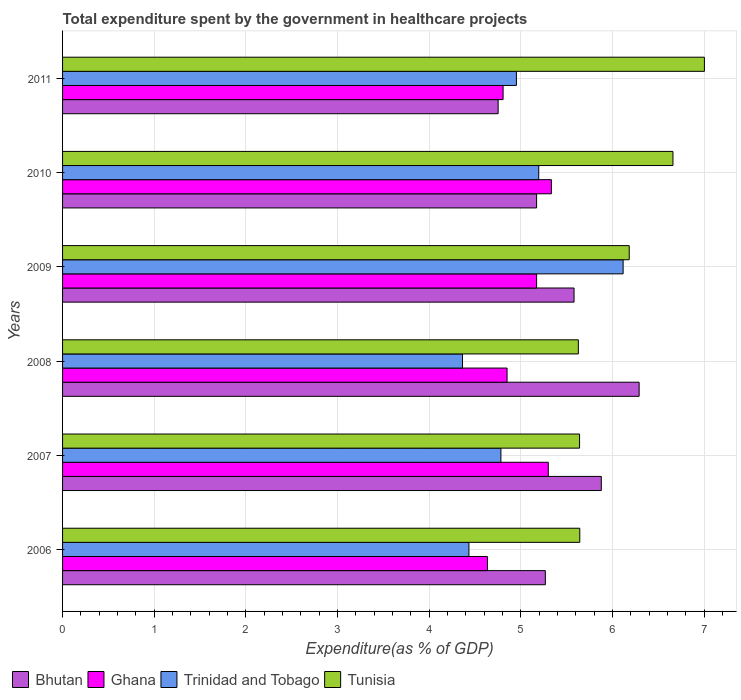What is the label of the 3rd group of bars from the top?
Your answer should be very brief. 2009. In how many cases, is the number of bars for a given year not equal to the number of legend labels?
Keep it short and to the point. 0. What is the total expenditure spent by the government in healthcare projects in Bhutan in 2009?
Keep it short and to the point. 5.58. Across all years, what is the maximum total expenditure spent by the government in healthcare projects in Bhutan?
Give a very brief answer. 6.29. Across all years, what is the minimum total expenditure spent by the government in healthcare projects in Tunisia?
Give a very brief answer. 5.63. In which year was the total expenditure spent by the government in healthcare projects in Tunisia maximum?
Your answer should be compact. 2011. In which year was the total expenditure spent by the government in healthcare projects in Trinidad and Tobago minimum?
Your response must be concise. 2008. What is the total total expenditure spent by the government in healthcare projects in Tunisia in the graph?
Provide a succinct answer. 36.76. What is the difference between the total expenditure spent by the government in healthcare projects in Bhutan in 2006 and that in 2011?
Your answer should be compact. 0.52. What is the difference between the total expenditure spent by the government in healthcare projects in Tunisia in 2010 and the total expenditure spent by the government in healthcare projects in Trinidad and Tobago in 2007?
Give a very brief answer. 1.88. What is the average total expenditure spent by the government in healthcare projects in Bhutan per year?
Your answer should be compact. 5.49. In the year 2011, what is the difference between the total expenditure spent by the government in healthcare projects in Bhutan and total expenditure spent by the government in healthcare projects in Trinidad and Tobago?
Your response must be concise. -0.2. In how many years, is the total expenditure spent by the government in healthcare projects in Trinidad and Tobago greater than 2.2 %?
Provide a short and direct response. 6. What is the ratio of the total expenditure spent by the government in healthcare projects in Bhutan in 2007 to that in 2010?
Make the answer very short. 1.14. Is the total expenditure spent by the government in healthcare projects in Bhutan in 2006 less than that in 2007?
Provide a succinct answer. Yes. What is the difference between the highest and the second highest total expenditure spent by the government in healthcare projects in Trinidad and Tobago?
Offer a very short reply. 0.92. What is the difference between the highest and the lowest total expenditure spent by the government in healthcare projects in Ghana?
Your response must be concise. 0.7. Is the sum of the total expenditure spent by the government in healthcare projects in Trinidad and Tobago in 2009 and 2011 greater than the maximum total expenditure spent by the government in healthcare projects in Tunisia across all years?
Offer a very short reply. Yes. Is it the case that in every year, the sum of the total expenditure spent by the government in healthcare projects in Ghana and total expenditure spent by the government in healthcare projects in Trinidad and Tobago is greater than the sum of total expenditure spent by the government in healthcare projects in Bhutan and total expenditure spent by the government in healthcare projects in Tunisia?
Your answer should be very brief. No. What does the 4th bar from the top in 2010 represents?
Your answer should be compact. Bhutan. What does the 3rd bar from the bottom in 2008 represents?
Your answer should be very brief. Trinidad and Tobago. Is it the case that in every year, the sum of the total expenditure spent by the government in healthcare projects in Tunisia and total expenditure spent by the government in healthcare projects in Bhutan is greater than the total expenditure spent by the government in healthcare projects in Ghana?
Keep it short and to the point. Yes. Are all the bars in the graph horizontal?
Your answer should be compact. Yes. What is the difference between two consecutive major ticks on the X-axis?
Give a very brief answer. 1. How many legend labels are there?
Offer a terse response. 4. What is the title of the graph?
Provide a short and direct response. Total expenditure spent by the government in healthcare projects. What is the label or title of the X-axis?
Give a very brief answer. Expenditure(as % of GDP). What is the label or title of the Y-axis?
Provide a short and direct response. Years. What is the Expenditure(as % of GDP) of Bhutan in 2006?
Give a very brief answer. 5.27. What is the Expenditure(as % of GDP) in Ghana in 2006?
Ensure brevity in your answer.  4.64. What is the Expenditure(as % of GDP) of Trinidad and Tobago in 2006?
Provide a short and direct response. 4.43. What is the Expenditure(as % of GDP) of Tunisia in 2006?
Offer a very short reply. 5.64. What is the Expenditure(as % of GDP) of Bhutan in 2007?
Make the answer very short. 5.88. What is the Expenditure(as % of GDP) in Ghana in 2007?
Provide a succinct answer. 5.3. What is the Expenditure(as % of GDP) in Trinidad and Tobago in 2007?
Make the answer very short. 4.78. What is the Expenditure(as % of GDP) in Tunisia in 2007?
Offer a very short reply. 5.64. What is the Expenditure(as % of GDP) of Bhutan in 2008?
Provide a short and direct response. 6.29. What is the Expenditure(as % of GDP) of Ghana in 2008?
Your answer should be compact. 4.85. What is the Expenditure(as % of GDP) in Trinidad and Tobago in 2008?
Your answer should be very brief. 4.36. What is the Expenditure(as % of GDP) in Tunisia in 2008?
Your answer should be compact. 5.63. What is the Expenditure(as % of GDP) in Bhutan in 2009?
Provide a succinct answer. 5.58. What is the Expenditure(as % of GDP) in Ghana in 2009?
Your answer should be compact. 5.17. What is the Expenditure(as % of GDP) in Trinidad and Tobago in 2009?
Provide a succinct answer. 6.12. What is the Expenditure(as % of GDP) in Tunisia in 2009?
Provide a succinct answer. 6.18. What is the Expenditure(as % of GDP) in Bhutan in 2010?
Ensure brevity in your answer.  5.17. What is the Expenditure(as % of GDP) of Ghana in 2010?
Provide a succinct answer. 5.33. What is the Expenditure(as % of GDP) in Trinidad and Tobago in 2010?
Your answer should be compact. 5.2. What is the Expenditure(as % of GDP) of Tunisia in 2010?
Keep it short and to the point. 6.66. What is the Expenditure(as % of GDP) of Bhutan in 2011?
Your answer should be very brief. 4.75. What is the Expenditure(as % of GDP) in Ghana in 2011?
Offer a very short reply. 4.81. What is the Expenditure(as % of GDP) in Trinidad and Tobago in 2011?
Ensure brevity in your answer.  4.95. What is the Expenditure(as % of GDP) in Tunisia in 2011?
Make the answer very short. 7. Across all years, what is the maximum Expenditure(as % of GDP) in Bhutan?
Your answer should be very brief. 6.29. Across all years, what is the maximum Expenditure(as % of GDP) of Ghana?
Provide a succinct answer. 5.33. Across all years, what is the maximum Expenditure(as % of GDP) in Trinidad and Tobago?
Make the answer very short. 6.12. Across all years, what is the maximum Expenditure(as % of GDP) in Tunisia?
Give a very brief answer. 7. Across all years, what is the minimum Expenditure(as % of GDP) in Bhutan?
Your response must be concise. 4.75. Across all years, what is the minimum Expenditure(as % of GDP) of Ghana?
Make the answer very short. 4.64. Across all years, what is the minimum Expenditure(as % of GDP) in Trinidad and Tobago?
Give a very brief answer. 4.36. Across all years, what is the minimum Expenditure(as % of GDP) in Tunisia?
Keep it short and to the point. 5.63. What is the total Expenditure(as % of GDP) of Bhutan in the graph?
Offer a terse response. 32.95. What is the total Expenditure(as % of GDP) in Ghana in the graph?
Your response must be concise. 30.1. What is the total Expenditure(as % of GDP) in Trinidad and Tobago in the graph?
Provide a succinct answer. 29.85. What is the total Expenditure(as % of GDP) in Tunisia in the graph?
Your answer should be very brief. 36.76. What is the difference between the Expenditure(as % of GDP) in Bhutan in 2006 and that in 2007?
Keep it short and to the point. -0.61. What is the difference between the Expenditure(as % of GDP) of Ghana in 2006 and that in 2007?
Your answer should be compact. -0.66. What is the difference between the Expenditure(as % of GDP) of Trinidad and Tobago in 2006 and that in 2007?
Keep it short and to the point. -0.35. What is the difference between the Expenditure(as % of GDP) in Tunisia in 2006 and that in 2007?
Your answer should be very brief. 0. What is the difference between the Expenditure(as % of GDP) in Bhutan in 2006 and that in 2008?
Offer a terse response. -1.02. What is the difference between the Expenditure(as % of GDP) in Ghana in 2006 and that in 2008?
Offer a very short reply. -0.21. What is the difference between the Expenditure(as % of GDP) of Trinidad and Tobago in 2006 and that in 2008?
Make the answer very short. 0.07. What is the difference between the Expenditure(as % of GDP) in Tunisia in 2006 and that in 2008?
Your answer should be very brief. 0.02. What is the difference between the Expenditure(as % of GDP) of Bhutan in 2006 and that in 2009?
Offer a terse response. -0.31. What is the difference between the Expenditure(as % of GDP) of Ghana in 2006 and that in 2009?
Your answer should be compact. -0.54. What is the difference between the Expenditure(as % of GDP) in Trinidad and Tobago in 2006 and that in 2009?
Keep it short and to the point. -1.68. What is the difference between the Expenditure(as % of GDP) of Tunisia in 2006 and that in 2009?
Your answer should be compact. -0.54. What is the difference between the Expenditure(as % of GDP) in Bhutan in 2006 and that in 2010?
Provide a succinct answer. 0.1. What is the difference between the Expenditure(as % of GDP) in Ghana in 2006 and that in 2010?
Your answer should be compact. -0.7. What is the difference between the Expenditure(as % of GDP) in Trinidad and Tobago in 2006 and that in 2010?
Your response must be concise. -0.76. What is the difference between the Expenditure(as % of GDP) in Tunisia in 2006 and that in 2010?
Your answer should be very brief. -1.02. What is the difference between the Expenditure(as % of GDP) of Bhutan in 2006 and that in 2011?
Provide a succinct answer. 0.52. What is the difference between the Expenditure(as % of GDP) of Ghana in 2006 and that in 2011?
Provide a succinct answer. -0.17. What is the difference between the Expenditure(as % of GDP) in Trinidad and Tobago in 2006 and that in 2011?
Offer a very short reply. -0.52. What is the difference between the Expenditure(as % of GDP) in Tunisia in 2006 and that in 2011?
Your answer should be very brief. -1.36. What is the difference between the Expenditure(as % of GDP) in Bhutan in 2007 and that in 2008?
Offer a terse response. -0.41. What is the difference between the Expenditure(as % of GDP) in Ghana in 2007 and that in 2008?
Your answer should be very brief. 0.45. What is the difference between the Expenditure(as % of GDP) in Trinidad and Tobago in 2007 and that in 2008?
Offer a terse response. 0.42. What is the difference between the Expenditure(as % of GDP) of Tunisia in 2007 and that in 2008?
Ensure brevity in your answer.  0.01. What is the difference between the Expenditure(as % of GDP) of Bhutan in 2007 and that in 2009?
Offer a terse response. 0.3. What is the difference between the Expenditure(as % of GDP) of Ghana in 2007 and that in 2009?
Keep it short and to the point. 0.13. What is the difference between the Expenditure(as % of GDP) in Trinidad and Tobago in 2007 and that in 2009?
Your answer should be compact. -1.33. What is the difference between the Expenditure(as % of GDP) of Tunisia in 2007 and that in 2009?
Your response must be concise. -0.54. What is the difference between the Expenditure(as % of GDP) of Bhutan in 2007 and that in 2010?
Your answer should be very brief. 0.71. What is the difference between the Expenditure(as % of GDP) of Ghana in 2007 and that in 2010?
Give a very brief answer. -0.03. What is the difference between the Expenditure(as % of GDP) in Trinidad and Tobago in 2007 and that in 2010?
Offer a very short reply. -0.41. What is the difference between the Expenditure(as % of GDP) of Tunisia in 2007 and that in 2010?
Keep it short and to the point. -1.02. What is the difference between the Expenditure(as % of GDP) of Bhutan in 2007 and that in 2011?
Your answer should be compact. 1.13. What is the difference between the Expenditure(as % of GDP) of Ghana in 2007 and that in 2011?
Ensure brevity in your answer.  0.49. What is the difference between the Expenditure(as % of GDP) in Trinidad and Tobago in 2007 and that in 2011?
Provide a succinct answer. -0.17. What is the difference between the Expenditure(as % of GDP) of Tunisia in 2007 and that in 2011?
Keep it short and to the point. -1.36. What is the difference between the Expenditure(as % of GDP) of Bhutan in 2008 and that in 2009?
Make the answer very short. 0.71. What is the difference between the Expenditure(as % of GDP) of Ghana in 2008 and that in 2009?
Make the answer very short. -0.32. What is the difference between the Expenditure(as % of GDP) of Trinidad and Tobago in 2008 and that in 2009?
Provide a succinct answer. -1.75. What is the difference between the Expenditure(as % of GDP) in Tunisia in 2008 and that in 2009?
Make the answer very short. -0.56. What is the difference between the Expenditure(as % of GDP) of Bhutan in 2008 and that in 2010?
Keep it short and to the point. 1.12. What is the difference between the Expenditure(as % of GDP) of Ghana in 2008 and that in 2010?
Offer a very short reply. -0.48. What is the difference between the Expenditure(as % of GDP) of Trinidad and Tobago in 2008 and that in 2010?
Ensure brevity in your answer.  -0.83. What is the difference between the Expenditure(as % of GDP) of Tunisia in 2008 and that in 2010?
Your response must be concise. -1.03. What is the difference between the Expenditure(as % of GDP) in Bhutan in 2008 and that in 2011?
Give a very brief answer. 1.54. What is the difference between the Expenditure(as % of GDP) in Ghana in 2008 and that in 2011?
Your answer should be very brief. 0.04. What is the difference between the Expenditure(as % of GDP) in Trinidad and Tobago in 2008 and that in 2011?
Provide a succinct answer. -0.59. What is the difference between the Expenditure(as % of GDP) in Tunisia in 2008 and that in 2011?
Give a very brief answer. -1.38. What is the difference between the Expenditure(as % of GDP) in Bhutan in 2009 and that in 2010?
Make the answer very short. 0.41. What is the difference between the Expenditure(as % of GDP) of Ghana in 2009 and that in 2010?
Provide a succinct answer. -0.16. What is the difference between the Expenditure(as % of GDP) of Trinidad and Tobago in 2009 and that in 2010?
Give a very brief answer. 0.92. What is the difference between the Expenditure(as % of GDP) of Tunisia in 2009 and that in 2010?
Provide a short and direct response. -0.48. What is the difference between the Expenditure(as % of GDP) in Bhutan in 2009 and that in 2011?
Provide a short and direct response. 0.83. What is the difference between the Expenditure(as % of GDP) of Ghana in 2009 and that in 2011?
Offer a terse response. 0.37. What is the difference between the Expenditure(as % of GDP) of Trinidad and Tobago in 2009 and that in 2011?
Provide a succinct answer. 1.16. What is the difference between the Expenditure(as % of GDP) in Tunisia in 2009 and that in 2011?
Offer a terse response. -0.82. What is the difference between the Expenditure(as % of GDP) in Bhutan in 2010 and that in 2011?
Your answer should be compact. 0.42. What is the difference between the Expenditure(as % of GDP) in Ghana in 2010 and that in 2011?
Your answer should be very brief. 0.53. What is the difference between the Expenditure(as % of GDP) of Trinidad and Tobago in 2010 and that in 2011?
Your answer should be very brief. 0.24. What is the difference between the Expenditure(as % of GDP) of Tunisia in 2010 and that in 2011?
Offer a very short reply. -0.34. What is the difference between the Expenditure(as % of GDP) of Bhutan in 2006 and the Expenditure(as % of GDP) of Ghana in 2007?
Your answer should be compact. -0.03. What is the difference between the Expenditure(as % of GDP) of Bhutan in 2006 and the Expenditure(as % of GDP) of Trinidad and Tobago in 2007?
Make the answer very short. 0.48. What is the difference between the Expenditure(as % of GDP) in Bhutan in 2006 and the Expenditure(as % of GDP) in Tunisia in 2007?
Your answer should be very brief. -0.37. What is the difference between the Expenditure(as % of GDP) of Ghana in 2006 and the Expenditure(as % of GDP) of Trinidad and Tobago in 2007?
Make the answer very short. -0.15. What is the difference between the Expenditure(as % of GDP) in Ghana in 2006 and the Expenditure(as % of GDP) in Tunisia in 2007?
Offer a terse response. -1.01. What is the difference between the Expenditure(as % of GDP) of Trinidad and Tobago in 2006 and the Expenditure(as % of GDP) of Tunisia in 2007?
Provide a succinct answer. -1.21. What is the difference between the Expenditure(as % of GDP) of Bhutan in 2006 and the Expenditure(as % of GDP) of Ghana in 2008?
Provide a short and direct response. 0.42. What is the difference between the Expenditure(as % of GDP) of Bhutan in 2006 and the Expenditure(as % of GDP) of Trinidad and Tobago in 2008?
Your answer should be compact. 0.9. What is the difference between the Expenditure(as % of GDP) in Bhutan in 2006 and the Expenditure(as % of GDP) in Tunisia in 2008?
Your answer should be compact. -0.36. What is the difference between the Expenditure(as % of GDP) of Ghana in 2006 and the Expenditure(as % of GDP) of Trinidad and Tobago in 2008?
Offer a terse response. 0.27. What is the difference between the Expenditure(as % of GDP) of Ghana in 2006 and the Expenditure(as % of GDP) of Tunisia in 2008?
Offer a terse response. -0.99. What is the difference between the Expenditure(as % of GDP) in Trinidad and Tobago in 2006 and the Expenditure(as % of GDP) in Tunisia in 2008?
Offer a very short reply. -1.19. What is the difference between the Expenditure(as % of GDP) in Bhutan in 2006 and the Expenditure(as % of GDP) in Ghana in 2009?
Offer a terse response. 0.1. What is the difference between the Expenditure(as % of GDP) in Bhutan in 2006 and the Expenditure(as % of GDP) in Trinidad and Tobago in 2009?
Keep it short and to the point. -0.85. What is the difference between the Expenditure(as % of GDP) in Bhutan in 2006 and the Expenditure(as % of GDP) in Tunisia in 2009?
Ensure brevity in your answer.  -0.92. What is the difference between the Expenditure(as % of GDP) in Ghana in 2006 and the Expenditure(as % of GDP) in Trinidad and Tobago in 2009?
Offer a very short reply. -1.48. What is the difference between the Expenditure(as % of GDP) of Ghana in 2006 and the Expenditure(as % of GDP) of Tunisia in 2009?
Give a very brief answer. -1.55. What is the difference between the Expenditure(as % of GDP) of Trinidad and Tobago in 2006 and the Expenditure(as % of GDP) of Tunisia in 2009?
Give a very brief answer. -1.75. What is the difference between the Expenditure(as % of GDP) of Bhutan in 2006 and the Expenditure(as % of GDP) of Ghana in 2010?
Your response must be concise. -0.07. What is the difference between the Expenditure(as % of GDP) of Bhutan in 2006 and the Expenditure(as % of GDP) of Trinidad and Tobago in 2010?
Provide a short and direct response. 0.07. What is the difference between the Expenditure(as % of GDP) in Bhutan in 2006 and the Expenditure(as % of GDP) in Tunisia in 2010?
Give a very brief answer. -1.39. What is the difference between the Expenditure(as % of GDP) of Ghana in 2006 and the Expenditure(as % of GDP) of Trinidad and Tobago in 2010?
Your answer should be very brief. -0.56. What is the difference between the Expenditure(as % of GDP) of Ghana in 2006 and the Expenditure(as % of GDP) of Tunisia in 2010?
Offer a very short reply. -2.02. What is the difference between the Expenditure(as % of GDP) in Trinidad and Tobago in 2006 and the Expenditure(as % of GDP) in Tunisia in 2010?
Your answer should be very brief. -2.23. What is the difference between the Expenditure(as % of GDP) of Bhutan in 2006 and the Expenditure(as % of GDP) of Ghana in 2011?
Offer a terse response. 0.46. What is the difference between the Expenditure(as % of GDP) of Bhutan in 2006 and the Expenditure(as % of GDP) of Trinidad and Tobago in 2011?
Provide a short and direct response. 0.32. What is the difference between the Expenditure(as % of GDP) in Bhutan in 2006 and the Expenditure(as % of GDP) in Tunisia in 2011?
Your response must be concise. -1.74. What is the difference between the Expenditure(as % of GDP) of Ghana in 2006 and the Expenditure(as % of GDP) of Trinidad and Tobago in 2011?
Your answer should be very brief. -0.32. What is the difference between the Expenditure(as % of GDP) in Ghana in 2006 and the Expenditure(as % of GDP) in Tunisia in 2011?
Your answer should be compact. -2.37. What is the difference between the Expenditure(as % of GDP) in Trinidad and Tobago in 2006 and the Expenditure(as % of GDP) in Tunisia in 2011?
Make the answer very short. -2.57. What is the difference between the Expenditure(as % of GDP) in Bhutan in 2007 and the Expenditure(as % of GDP) in Ghana in 2008?
Provide a short and direct response. 1.03. What is the difference between the Expenditure(as % of GDP) of Bhutan in 2007 and the Expenditure(as % of GDP) of Trinidad and Tobago in 2008?
Provide a succinct answer. 1.51. What is the difference between the Expenditure(as % of GDP) in Bhutan in 2007 and the Expenditure(as % of GDP) in Tunisia in 2008?
Your response must be concise. 0.25. What is the difference between the Expenditure(as % of GDP) in Ghana in 2007 and the Expenditure(as % of GDP) in Trinidad and Tobago in 2008?
Give a very brief answer. 0.94. What is the difference between the Expenditure(as % of GDP) in Ghana in 2007 and the Expenditure(as % of GDP) in Tunisia in 2008?
Ensure brevity in your answer.  -0.33. What is the difference between the Expenditure(as % of GDP) in Trinidad and Tobago in 2007 and the Expenditure(as % of GDP) in Tunisia in 2008?
Offer a terse response. -0.84. What is the difference between the Expenditure(as % of GDP) of Bhutan in 2007 and the Expenditure(as % of GDP) of Ghana in 2009?
Offer a very short reply. 0.71. What is the difference between the Expenditure(as % of GDP) in Bhutan in 2007 and the Expenditure(as % of GDP) in Trinidad and Tobago in 2009?
Make the answer very short. -0.24. What is the difference between the Expenditure(as % of GDP) in Bhutan in 2007 and the Expenditure(as % of GDP) in Tunisia in 2009?
Ensure brevity in your answer.  -0.3. What is the difference between the Expenditure(as % of GDP) of Ghana in 2007 and the Expenditure(as % of GDP) of Trinidad and Tobago in 2009?
Make the answer very short. -0.82. What is the difference between the Expenditure(as % of GDP) of Ghana in 2007 and the Expenditure(as % of GDP) of Tunisia in 2009?
Your answer should be very brief. -0.88. What is the difference between the Expenditure(as % of GDP) in Trinidad and Tobago in 2007 and the Expenditure(as % of GDP) in Tunisia in 2009?
Your answer should be compact. -1.4. What is the difference between the Expenditure(as % of GDP) in Bhutan in 2007 and the Expenditure(as % of GDP) in Ghana in 2010?
Provide a short and direct response. 0.54. What is the difference between the Expenditure(as % of GDP) of Bhutan in 2007 and the Expenditure(as % of GDP) of Trinidad and Tobago in 2010?
Keep it short and to the point. 0.68. What is the difference between the Expenditure(as % of GDP) of Bhutan in 2007 and the Expenditure(as % of GDP) of Tunisia in 2010?
Make the answer very short. -0.78. What is the difference between the Expenditure(as % of GDP) in Ghana in 2007 and the Expenditure(as % of GDP) in Trinidad and Tobago in 2010?
Your answer should be very brief. 0.1. What is the difference between the Expenditure(as % of GDP) in Ghana in 2007 and the Expenditure(as % of GDP) in Tunisia in 2010?
Provide a short and direct response. -1.36. What is the difference between the Expenditure(as % of GDP) of Trinidad and Tobago in 2007 and the Expenditure(as % of GDP) of Tunisia in 2010?
Your response must be concise. -1.88. What is the difference between the Expenditure(as % of GDP) in Bhutan in 2007 and the Expenditure(as % of GDP) in Ghana in 2011?
Provide a succinct answer. 1.07. What is the difference between the Expenditure(as % of GDP) in Bhutan in 2007 and the Expenditure(as % of GDP) in Trinidad and Tobago in 2011?
Keep it short and to the point. 0.93. What is the difference between the Expenditure(as % of GDP) in Bhutan in 2007 and the Expenditure(as % of GDP) in Tunisia in 2011?
Give a very brief answer. -1.12. What is the difference between the Expenditure(as % of GDP) of Ghana in 2007 and the Expenditure(as % of GDP) of Trinidad and Tobago in 2011?
Provide a short and direct response. 0.35. What is the difference between the Expenditure(as % of GDP) in Ghana in 2007 and the Expenditure(as % of GDP) in Tunisia in 2011?
Offer a very short reply. -1.7. What is the difference between the Expenditure(as % of GDP) in Trinidad and Tobago in 2007 and the Expenditure(as % of GDP) in Tunisia in 2011?
Provide a short and direct response. -2.22. What is the difference between the Expenditure(as % of GDP) of Bhutan in 2008 and the Expenditure(as % of GDP) of Ghana in 2009?
Provide a succinct answer. 1.12. What is the difference between the Expenditure(as % of GDP) of Bhutan in 2008 and the Expenditure(as % of GDP) of Trinidad and Tobago in 2009?
Your response must be concise. 0.17. What is the difference between the Expenditure(as % of GDP) in Bhutan in 2008 and the Expenditure(as % of GDP) in Tunisia in 2009?
Offer a very short reply. 0.11. What is the difference between the Expenditure(as % of GDP) of Ghana in 2008 and the Expenditure(as % of GDP) of Trinidad and Tobago in 2009?
Give a very brief answer. -1.27. What is the difference between the Expenditure(as % of GDP) in Ghana in 2008 and the Expenditure(as % of GDP) in Tunisia in 2009?
Make the answer very short. -1.33. What is the difference between the Expenditure(as % of GDP) in Trinidad and Tobago in 2008 and the Expenditure(as % of GDP) in Tunisia in 2009?
Give a very brief answer. -1.82. What is the difference between the Expenditure(as % of GDP) of Bhutan in 2008 and the Expenditure(as % of GDP) of Ghana in 2010?
Your answer should be very brief. 0.96. What is the difference between the Expenditure(as % of GDP) of Bhutan in 2008 and the Expenditure(as % of GDP) of Trinidad and Tobago in 2010?
Provide a succinct answer. 1.1. What is the difference between the Expenditure(as % of GDP) in Bhutan in 2008 and the Expenditure(as % of GDP) in Tunisia in 2010?
Offer a very short reply. -0.37. What is the difference between the Expenditure(as % of GDP) of Ghana in 2008 and the Expenditure(as % of GDP) of Trinidad and Tobago in 2010?
Keep it short and to the point. -0.35. What is the difference between the Expenditure(as % of GDP) in Ghana in 2008 and the Expenditure(as % of GDP) in Tunisia in 2010?
Keep it short and to the point. -1.81. What is the difference between the Expenditure(as % of GDP) of Trinidad and Tobago in 2008 and the Expenditure(as % of GDP) of Tunisia in 2010?
Your response must be concise. -2.3. What is the difference between the Expenditure(as % of GDP) in Bhutan in 2008 and the Expenditure(as % of GDP) in Ghana in 2011?
Provide a succinct answer. 1.48. What is the difference between the Expenditure(as % of GDP) of Bhutan in 2008 and the Expenditure(as % of GDP) of Trinidad and Tobago in 2011?
Provide a short and direct response. 1.34. What is the difference between the Expenditure(as % of GDP) of Bhutan in 2008 and the Expenditure(as % of GDP) of Tunisia in 2011?
Provide a short and direct response. -0.71. What is the difference between the Expenditure(as % of GDP) of Ghana in 2008 and the Expenditure(as % of GDP) of Trinidad and Tobago in 2011?
Provide a short and direct response. -0.1. What is the difference between the Expenditure(as % of GDP) of Ghana in 2008 and the Expenditure(as % of GDP) of Tunisia in 2011?
Your answer should be compact. -2.15. What is the difference between the Expenditure(as % of GDP) in Trinidad and Tobago in 2008 and the Expenditure(as % of GDP) in Tunisia in 2011?
Give a very brief answer. -2.64. What is the difference between the Expenditure(as % of GDP) in Bhutan in 2009 and the Expenditure(as % of GDP) in Ghana in 2010?
Offer a terse response. 0.25. What is the difference between the Expenditure(as % of GDP) of Bhutan in 2009 and the Expenditure(as % of GDP) of Trinidad and Tobago in 2010?
Ensure brevity in your answer.  0.39. What is the difference between the Expenditure(as % of GDP) in Bhutan in 2009 and the Expenditure(as % of GDP) in Tunisia in 2010?
Make the answer very short. -1.08. What is the difference between the Expenditure(as % of GDP) of Ghana in 2009 and the Expenditure(as % of GDP) of Trinidad and Tobago in 2010?
Keep it short and to the point. -0.02. What is the difference between the Expenditure(as % of GDP) of Ghana in 2009 and the Expenditure(as % of GDP) of Tunisia in 2010?
Make the answer very short. -1.49. What is the difference between the Expenditure(as % of GDP) of Trinidad and Tobago in 2009 and the Expenditure(as % of GDP) of Tunisia in 2010?
Make the answer very short. -0.54. What is the difference between the Expenditure(as % of GDP) of Bhutan in 2009 and the Expenditure(as % of GDP) of Ghana in 2011?
Provide a succinct answer. 0.77. What is the difference between the Expenditure(as % of GDP) in Bhutan in 2009 and the Expenditure(as % of GDP) in Trinidad and Tobago in 2011?
Give a very brief answer. 0.63. What is the difference between the Expenditure(as % of GDP) of Bhutan in 2009 and the Expenditure(as % of GDP) of Tunisia in 2011?
Ensure brevity in your answer.  -1.42. What is the difference between the Expenditure(as % of GDP) of Ghana in 2009 and the Expenditure(as % of GDP) of Trinidad and Tobago in 2011?
Keep it short and to the point. 0.22. What is the difference between the Expenditure(as % of GDP) in Ghana in 2009 and the Expenditure(as % of GDP) in Tunisia in 2011?
Keep it short and to the point. -1.83. What is the difference between the Expenditure(as % of GDP) in Trinidad and Tobago in 2009 and the Expenditure(as % of GDP) in Tunisia in 2011?
Provide a short and direct response. -0.89. What is the difference between the Expenditure(as % of GDP) of Bhutan in 2010 and the Expenditure(as % of GDP) of Ghana in 2011?
Provide a short and direct response. 0.37. What is the difference between the Expenditure(as % of GDP) in Bhutan in 2010 and the Expenditure(as % of GDP) in Trinidad and Tobago in 2011?
Make the answer very short. 0.22. What is the difference between the Expenditure(as % of GDP) in Bhutan in 2010 and the Expenditure(as % of GDP) in Tunisia in 2011?
Offer a very short reply. -1.83. What is the difference between the Expenditure(as % of GDP) in Ghana in 2010 and the Expenditure(as % of GDP) in Trinidad and Tobago in 2011?
Give a very brief answer. 0.38. What is the difference between the Expenditure(as % of GDP) of Ghana in 2010 and the Expenditure(as % of GDP) of Tunisia in 2011?
Give a very brief answer. -1.67. What is the difference between the Expenditure(as % of GDP) in Trinidad and Tobago in 2010 and the Expenditure(as % of GDP) in Tunisia in 2011?
Your response must be concise. -1.81. What is the average Expenditure(as % of GDP) in Bhutan per year?
Ensure brevity in your answer.  5.49. What is the average Expenditure(as % of GDP) of Ghana per year?
Make the answer very short. 5.02. What is the average Expenditure(as % of GDP) in Trinidad and Tobago per year?
Give a very brief answer. 4.97. What is the average Expenditure(as % of GDP) in Tunisia per year?
Make the answer very short. 6.13. In the year 2006, what is the difference between the Expenditure(as % of GDP) of Bhutan and Expenditure(as % of GDP) of Ghana?
Offer a terse response. 0.63. In the year 2006, what is the difference between the Expenditure(as % of GDP) of Bhutan and Expenditure(as % of GDP) of Trinidad and Tobago?
Make the answer very short. 0.83. In the year 2006, what is the difference between the Expenditure(as % of GDP) of Bhutan and Expenditure(as % of GDP) of Tunisia?
Provide a short and direct response. -0.38. In the year 2006, what is the difference between the Expenditure(as % of GDP) of Ghana and Expenditure(as % of GDP) of Trinidad and Tobago?
Your answer should be compact. 0.2. In the year 2006, what is the difference between the Expenditure(as % of GDP) in Ghana and Expenditure(as % of GDP) in Tunisia?
Make the answer very short. -1.01. In the year 2006, what is the difference between the Expenditure(as % of GDP) in Trinidad and Tobago and Expenditure(as % of GDP) in Tunisia?
Make the answer very short. -1.21. In the year 2007, what is the difference between the Expenditure(as % of GDP) in Bhutan and Expenditure(as % of GDP) in Ghana?
Your response must be concise. 0.58. In the year 2007, what is the difference between the Expenditure(as % of GDP) in Bhutan and Expenditure(as % of GDP) in Trinidad and Tobago?
Your response must be concise. 1.1. In the year 2007, what is the difference between the Expenditure(as % of GDP) of Bhutan and Expenditure(as % of GDP) of Tunisia?
Keep it short and to the point. 0.24. In the year 2007, what is the difference between the Expenditure(as % of GDP) in Ghana and Expenditure(as % of GDP) in Trinidad and Tobago?
Offer a very short reply. 0.52. In the year 2007, what is the difference between the Expenditure(as % of GDP) in Ghana and Expenditure(as % of GDP) in Tunisia?
Your answer should be compact. -0.34. In the year 2007, what is the difference between the Expenditure(as % of GDP) in Trinidad and Tobago and Expenditure(as % of GDP) in Tunisia?
Your answer should be very brief. -0.86. In the year 2008, what is the difference between the Expenditure(as % of GDP) in Bhutan and Expenditure(as % of GDP) in Ghana?
Make the answer very short. 1.44. In the year 2008, what is the difference between the Expenditure(as % of GDP) in Bhutan and Expenditure(as % of GDP) in Trinidad and Tobago?
Ensure brevity in your answer.  1.93. In the year 2008, what is the difference between the Expenditure(as % of GDP) of Bhutan and Expenditure(as % of GDP) of Tunisia?
Your answer should be very brief. 0.66. In the year 2008, what is the difference between the Expenditure(as % of GDP) in Ghana and Expenditure(as % of GDP) in Trinidad and Tobago?
Provide a short and direct response. 0.49. In the year 2008, what is the difference between the Expenditure(as % of GDP) of Ghana and Expenditure(as % of GDP) of Tunisia?
Provide a succinct answer. -0.78. In the year 2008, what is the difference between the Expenditure(as % of GDP) in Trinidad and Tobago and Expenditure(as % of GDP) in Tunisia?
Your answer should be compact. -1.26. In the year 2009, what is the difference between the Expenditure(as % of GDP) of Bhutan and Expenditure(as % of GDP) of Ghana?
Make the answer very short. 0.41. In the year 2009, what is the difference between the Expenditure(as % of GDP) in Bhutan and Expenditure(as % of GDP) in Trinidad and Tobago?
Give a very brief answer. -0.54. In the year 2009, what is the difference between the Expenditure(as % of GDP) in Bhutan and Expenditure(as % of GDP) in Tunisia?
Make the answer very short. -0.6. In the year 2009, what is the difference between the Expenditure(as % of GDP) in Ghana and Expenditure(as % of GDP) in Trinidad and Tobago?
Your response must be concise. -0.94. In the year 2009, what is the difference between the Expenditure(as % of GDP) in Ghana and Expenditure(as % of GDP) in Tunisia?
Offer a very short reply. -1.01. In the year 2009, what is the difference between the Expenditure(as % of GDP) of Trinidad and Tobago and Expenditure(as % of GDP) of Tunisia?
Keep it short and to the point. -0.07. In the year 2010, what is the difference between the Expenditure(as % of GDP) in Bhutan and Expenditure(as % of GDP) in Ghana?
Keep it short and to the point. -0.16. In the year 2010, what is the difference between the Expenditure(as % of GDP) in Bhutan and Expenditure(as % of GDP) in Trinidad and Tobago?
Provide a succinct answer. -0.02. In the year 2010, what is the difference between the Expenditure(as % of GDP) in Bhutan and Expenditure(as % of GDP) in Tunisia?
Provide a short and direct response. -1.49. In the year 2010, what is the difference between the Expenditure(as % of GDP) in Ghana and Expenditure(as % of GDP) in Trinidad and Tobago?
Offer a terse response. 0.14. In the year 2010, what is the difference between the Expenditure(as % of GDP) of Ghana and Expenditure(as % of GDP) of Tunisia?
Your response must be concise. -1.33. In the year 2010, what is the difference between the Expenditure(as % of GDP) of Trinidad and Tobago and Expenditure(as % of GDP) of Tunisia?
Provide a short and direct response. -1.46. In the year 2011, what is the difference between the Expenditure(as % of GDP) in Bhutan and Expenditure(as % of GDP) in Ghana?
Offer a terse response. -0.05. In the year 2011, what is the difference between the Expenditure(as % of GDP) of Bhutan and Expenditure(as % of GDP) of Trinidad and Tobago?
Your answer should be very brief. -0.2. In the year 2011, what is the difference between the Expenditure(as % of GDP) in Bhutan and Expenditure(as % of GDP) in Tunisia?
Ensure brevity in your answer.  -2.25. In the year 2011, what is the difference between the Expenditure(as % of GDP) of Ghana and Expenditure(as % of GDP) of Trinidad and Tobago?
Offer a very short reply. -0.15. In the year 2011, what is the difference between the Expenditure(as % of GDP) in Ghana and Expenditure(as % of GDP) in Tunisia?
Your answer should be very brief. -2.2. In the year 2011, what is the difference between the Expenditure(as % of GDP) in Trinidad and Tobago and Expenditure(as % of GDP) in Tunisia?
Keep it short and to the point. -2.05. What is the ratio of the Expenditure(as % of GDP) in Bhutan in 2006 to that in 2007?
Provide a succinct answer. 0.9. What is the ratio of the Expenditure(as % of GDP) of Ghana in 2006 to that in 2007?
Ensure brevity in your answer.  0.87. What is the ratio of the Expenditure(as % of GDP) in Trinidad and Tobago in 2006 to that in 2007?
Offer a very short reply. 0.93. What is the ratio of the Expenditure(as % of GDP) of Bhutan in 2006 to that in 2008?
Keep it short and to the point. 0.84. What is the ratio of the Expenditure(as % of GDP) in Ghana in 2006 to that in 2008?
Give a very brief answer. 0.96. What is the ratio of the Expenditure(as % of GDP) in Trinidad and Tobago in 2006 to that in 2008?
Ensure brevity in your answer.  1.02. What is the ratio of the Expenditure(as % of GDP) of Bhutan in 2006 to that in 2009?
Provide a succinct answer. 0.94. What is the ratio of the Expenditure(as % of GDP) of Ghana in 2006 to that in 2009?
Your answer should be compact. 0.9. What is the ratio of the Expenditure(as % of GDP) in Trinidad and Tobago in 2006 to that in 2009?
Ensure brevity in your answer.  0.72. What is the ratio of the Expenditure(as % of GDP) in Tunisia in 2006 to that in 2009?
Keep it short and to the point. 0.91. What is the ratio of the Expenditure(as % of GDP) in Bhutan in 2006 to that in 2010?
Keep it short and to the point. 1.02. What is the ratio of the Expenditure(as % of GDP) in Ghana in 2006 to that in 2010?
Ensure brevity in your answer.  0.87. What is the ratio of the Expenditure(as % of GDP) in Trinidad and Tobago in 2006 to that in 2010?
Your answer should be very brief. 0.85. What is the ratio of the Expenditure(as % of GDP) in Tunisia in 2006 to that in 2010?
Provide a short and direct response. 0.85. What is the ratio of the Expenditure(as % of GDP) in Bhutan in 2006 to that in 2011?
Make the answer very short. 1.11. What is the ratio of the Expenditure(as % of GDP) in Ghana in 2006 to that in 2011?
Offer a very short reply. 0.96. What is the ratio of the Expenditure(as % of GDP) of Trinidad and Tobago in 2006 to that in 2011?
Give a very brief answer. 0.9. What is the ratio of the Expenditure(as % of GDP) of Tunisia in 2006 to that in 2011?
Provide a succinct answer. 0.81. What is the ratio of the Expenditure(as % of GDP) of Bhutan in 2007 to that in 2008?
Provide a short and direct response. 0.93. What is the ratio of the Expenditure(as % of GDP) of Ghana in 2007 to that in 2008?
Your answer should be compact. 1.09. What is the ratio of the Expenditure(as % of GDP) of Trinidad and Tobago in 2007 to that in 2008?
Keep it short and to the point. 1.1. What is the ratio of the Expenditure(as % of GDP) of Bhutan in 2007 to that in 2009?
Offer a very short reply. 1.05. What is the ratio of the Expenditure(as % of GDP) of Ghana in 2007 to that in 2009?
Give a very brief answer. 1.02. What is the ratio of the Expenditure(as % of GDP) in Trinidad and Tobago in 2007 to that in 2009?
Keep it short and to the point. 0.78. What is the ratio of the Expenditure(as % of GDP) in Tunisia in 2007 to that in 2009?
Offer a terse response. 0.91. What is the ratio of the Expenditure(as % of GDP) of Bhutan in 2007 to that in 2010?
Offer a terse response. 1.14. What is the ratio of the Expenditure(as % of GDP) of Ghana in 2007 to that in 2010?
Provide a succinct answer. 0.99. What is the ratio of the Expenditure(as % of GDP) of Trinidad and Tobago in 2007 to that in 2010?
Your answer should be very brief. 0.92. What is the ratio of the Expenditure(as % of GDP) of Tunisia in 2007 to that in 2010?
Ensure brevity in your answer.  0.85. What is the ratio of the Expenditure(as % of GDP) in Bhutan in 2007 to that in 2011?
Provide a short and direct response. 1.24. What is the ratio of the Expenditure(as % of GDP) in Ghana in 2007 to that in 2011?
Offer a very short reply. 1.1. What is the ratio of the Expenditure(as % of GDP) in Trinidad and Tobago in 2007 to that in 2011?
Give a very brief answer. 0.97. What is the ratio of the Expenditure(as % of GDP) of Tunisia in 2007 to that in 2011?
Give a very brief answer. 0.81. What is the ratio of the Expenditure(as % of GDP) of Bhutan in 2008 to that in 2009?
Offer a terse response. 1.13. What is the ratio of the Expenditure(as % of GDP) of Ghana in 2008 to that in 2009?
Offer a terse response. 0.94. What is the ratio of the Expenditure(as % of GDP) in Trinidad and Tobago in 2008 to that in 2009?
Your response must be concise. 0.71. What is the ratio of the Expenditure(as % of GDP) of Tunisia in 2008 to that in 2009?
Offer a very short reply. 0.91. What is the ratio of the Expenditure(as % of GDP) in Bhutan in 2008 to that in 2010?
Provide a succinct answer. 1.22. What is the ratio of the Expenditure(as % of GDP) of Ghana in 2008 to that in 2010?
Your answer should be compact. 0.91. What is the ratio of the Expenditure(as % of GDP) of Trinidad and Tobago in 2008 to that in 2010?
Make the answer very short. 0.84. What is the ratio of the Expenditure(as % of GDP) in Tunisia in 2008 to that in 2010?
Offer a very short reply. 0.84. What is the ratio of the Expenditure(as % of GDP) of Bhutan in 2008 to that in 2011?
Your answer should be compact. 1.32. What is the ratio of the Expenditure(as % of GDP) in Ghana in 2008 to that in 2011?
Your answer should be compact. 1.01. What is the ratio of the Expenditure(as % of GDP) of Trinidad and Tobago in 2008 to that in 2011?
Make the answer very short. 0.88. What is the ratio of the Expenditure(as % of GDP) of Tunisia in 2008 to that in 2011?
Provide a succinct answer. 0.8. What is the ratio of the Expenditure(as % of GDP) of Bhutan in 2009 to that in 2010?
Your answer should be compact. 1.08. What is the ratio of the Expenditure(as % of GDP) of Ghana in 2009 to that in 2010?
Ensure brevity in your answer.  0.97. What is the ratio of the Expenditure(as % of GDP) of Trinidad and Tobago in 2009 to that in 2010?
Offer a terse response. 1.18. What is the ratio of the Expenditure(as % of GDP) of Tunisia in 2009 to that in 2010?
Offer a terse response. 0.93. What is the ratio of the Expenditure(as % of GDP) in Bhutan in 2009 to that in 2011?
Keep it short and to the point. 1.17. What is the ratio of the Expenditure(as % of GDP) of Ghana in 2009 to that in 2011?
Your response must be concise. 1.08. What is the ratio of the Expenditure(as % of GDP) of Trinidad and Tobago in 2009 to that in 2011?
Provide a succinct answer. 1.24. What is the ratio of the Expenditure(as % of GDP) of Tunisia in 2009 to that in 2011?
Ensure brevity in your answer.  0.88. What is the ratio of the Expenditure(as % of GDP) in Bhutan in 2010 to that in 2011?
Provide a succinct answer. 1.09. What is the ratio of the Expenditure(as % of GDP) of Ghana in 2010 to that in 2011?
Make the answer very short. 1.11. What is the ratio of the Expenditure(as % of GDP) in Trinidad and Tobago in 2010 to that in 2011?
Offer a terse response. 1.05. What is the ratio of the Expenditure(as % of GDP) in Tunisia in 2010 to that in 2011?
Offer a terse response. 0.95. What is the difference between the highest and the second highest Expenditure(as % of GDP) of Bhutan?
Ensure brevity in your answer.  0.41. What is the difference between the highest and the second highest Expenditure(as % of GDP) of Ghana?
Your answer should be very brief. 0.03. What is the difference between the highest and the second highest Expenditure(as % of GDP) of Trinidad and Tobago?
Make the answer very short. 0.92. What is the difference between the highest and the second highest Expenditure(as % of GDP) of Tunisia?
Your response must be concise. 0.34. What is the difference between the highest and the lowest Expenditure(as % of GDP) in Bhutan?
Your response must be concise. 1.54. What is the difference between the highest and the lowest Expenditure(as % of GDP) in Ghana?
Ensure brevity in your answer.  0.7. What is the difference between the highest and the lowest Expenditure(as % of GDP) in Trinidad and Tobago?
Your answer should be very brief. 1.75. What is the difference between the highest and the lowest Expenditure(as % of GDP) in Tunisia?
Keep it short and to the point. 1.38. 